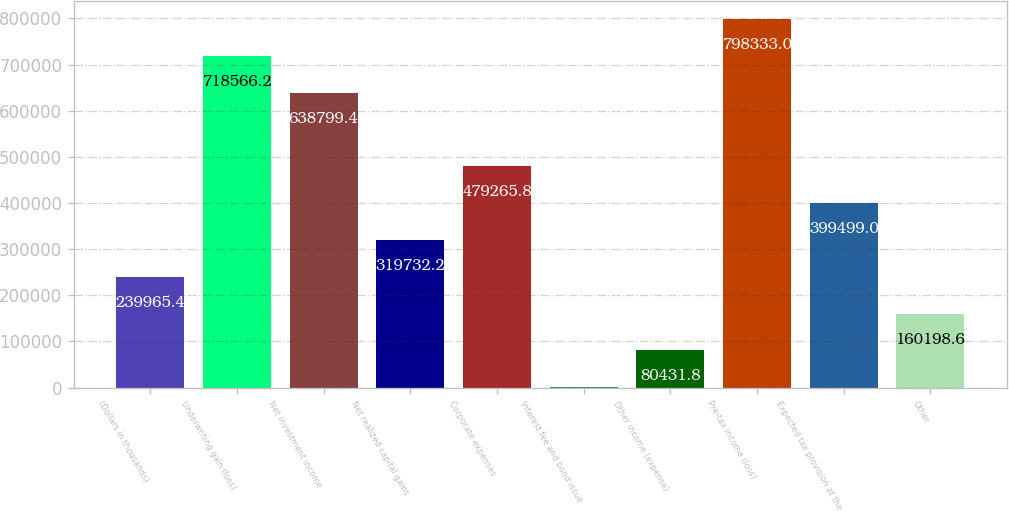<chart> <loc_0><loc_0><loc_500><loc_500><bar_chart><fcel>(Dollars in thousands)<fcel>Underwriting gain (loss)<fcel>Net investment income<fcel>Net realized capital gains<fcel>Corporate expenses<fcel>Interest fee and bond issue<fcel>Other income (expense)<fcel>Pre-tax income (loss)<fcel>Expected tax provision at the<fcel>Other<nl><fcel>239965<fcel>718566<fcel>638799<fcel>319732<fcel>479266<fcel>665<fcel>80431.8<fcel>798333<fcel>399499<fcel>160199<nl></chart> 